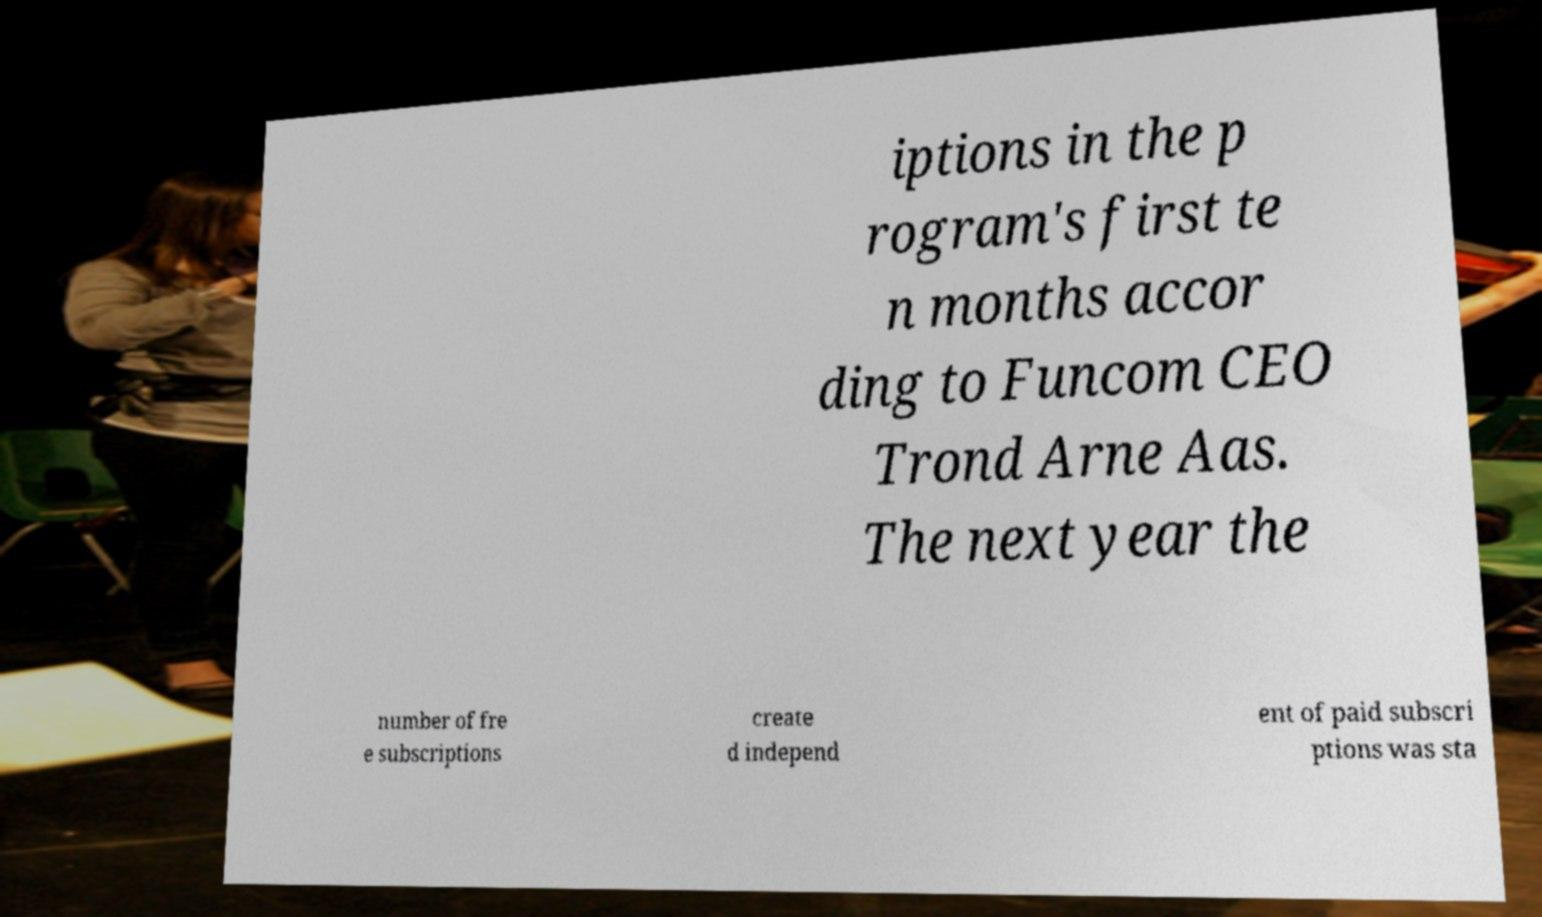Could you extract and type out the text from this image? iptions in the p rogram's first te n months accor ding to Funcom CEO Trond Arne Aas. The next year the number of fre e subscriptions create d independ ent of paid subscri ptions was sta 